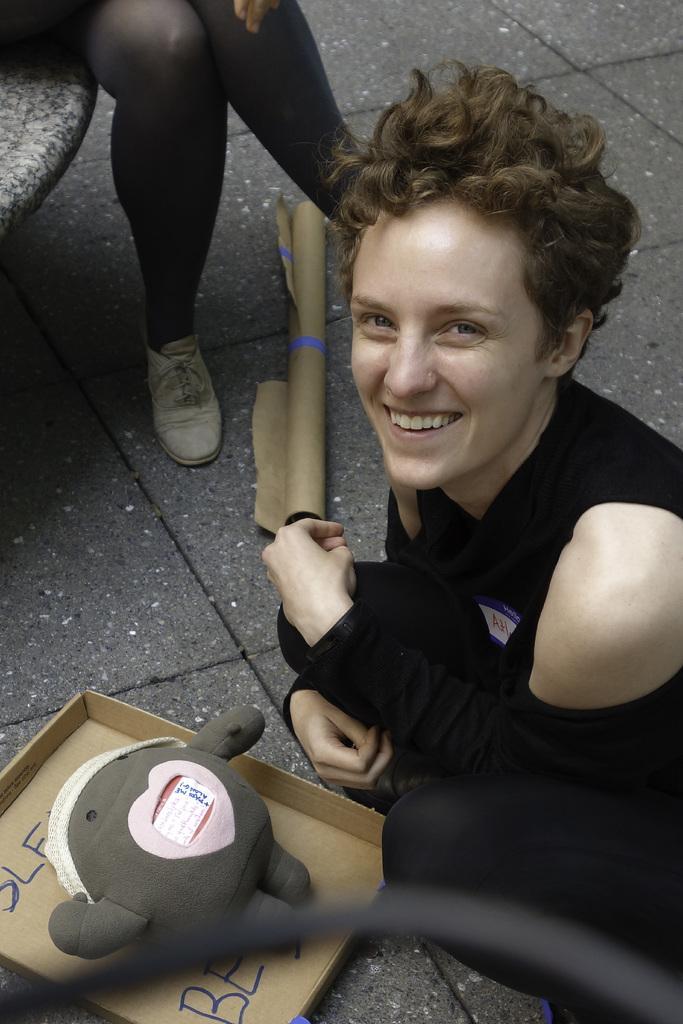Describe this image in one or two sentences. In this picture there is a woman who is wearing black dress. She is in a squat position. Beside her we can see the doll, which is kept on the cotton box. In the top left corner there is another woman who is the wearing black dress and white sneakers. She is sitting on the bench. 